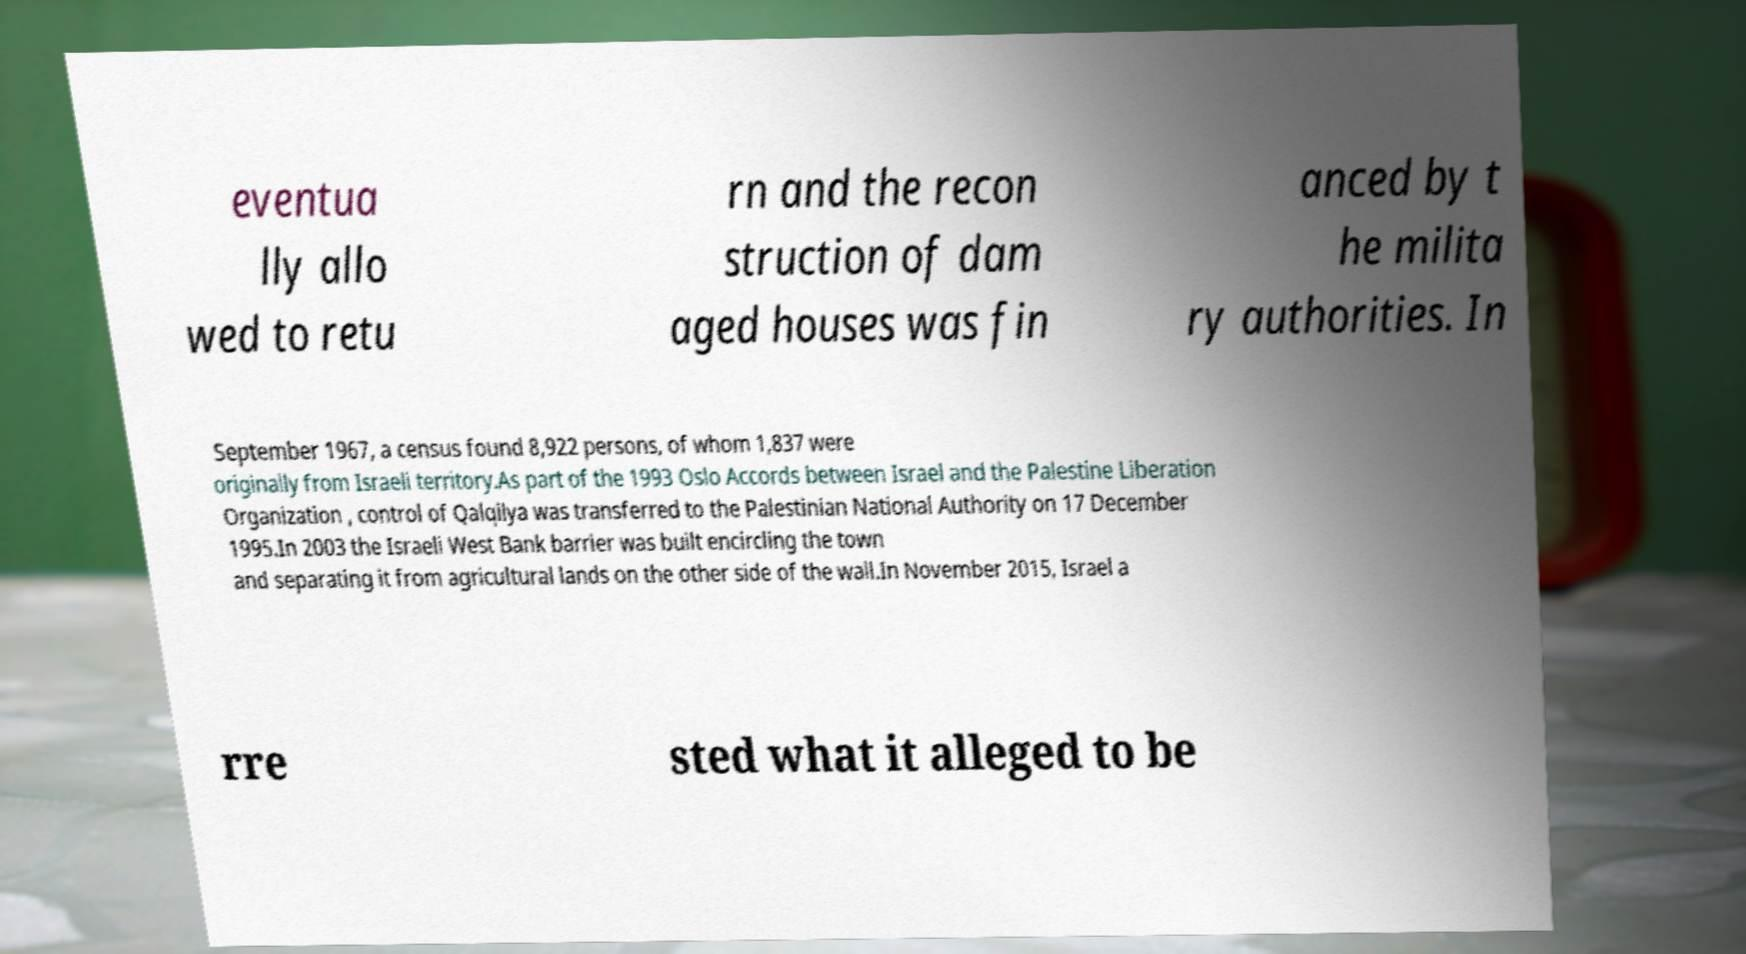For documentation purposes, I need the text within this image transcribed. Could you provide that? eventua lly allo wed to retu rn and the recon struction of dam aged houses was fin anced by t he milita ry authorities. In September 1967, a census found 8,922 persons, of whom 1,837 were originally from Israeli territory.As part of the 1993 Oslo Accords between Israel and the Palestine Liberation Organization , control of Qalqilya was transferred to the Palestinian National Authority on 17 December 1995.In 2003 the Israeli West Bank barrier was built encircling the town and separating it from agricultural lands on the other side of the wall.In November 2015, Israel a rre sted what it alleged to be 